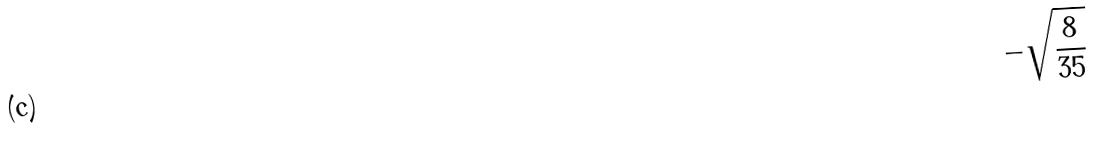<formula> <loc_0><loc_0><loc_500><loc_500>- \sqrt { \frac { 8 } { 3 5 } }</formula> 